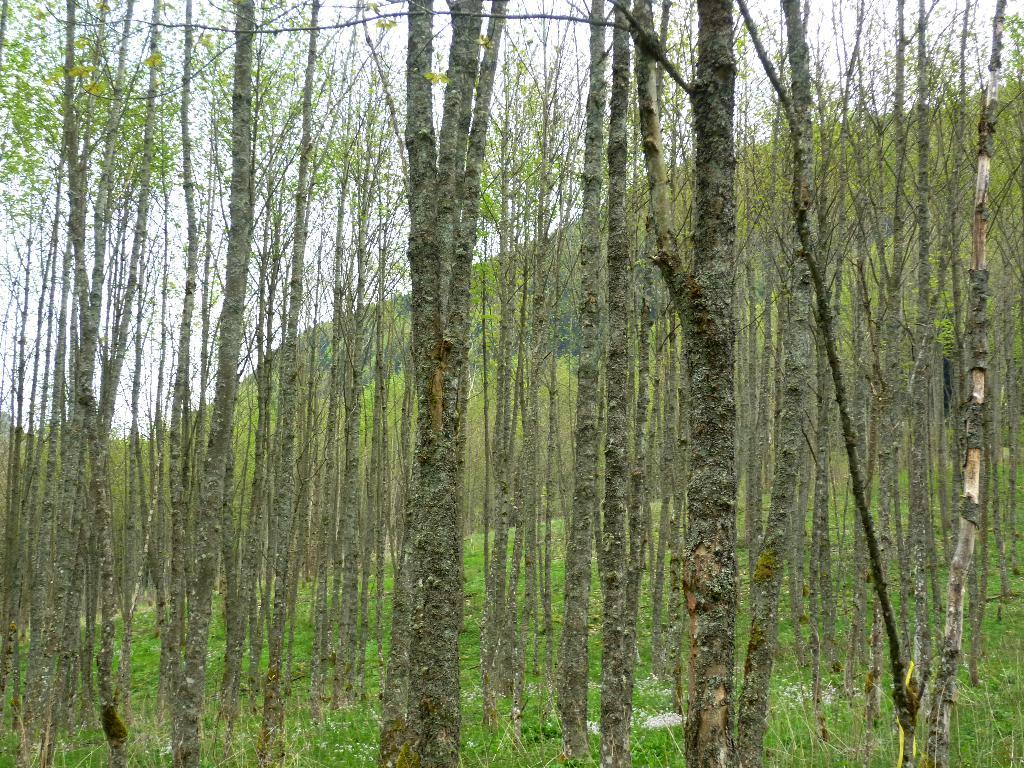What type of vegetation is present in the image? There are tall trees in the image. What else can be seen on the ground in the image? There is grass in the image. What is visible in the background of the image? The sky is visible in the image. What type of shoe can be seen hanging from the tallest tree in the image? There is no shoe present in the image, and therefore no such object can be observed hanging from the trees. 